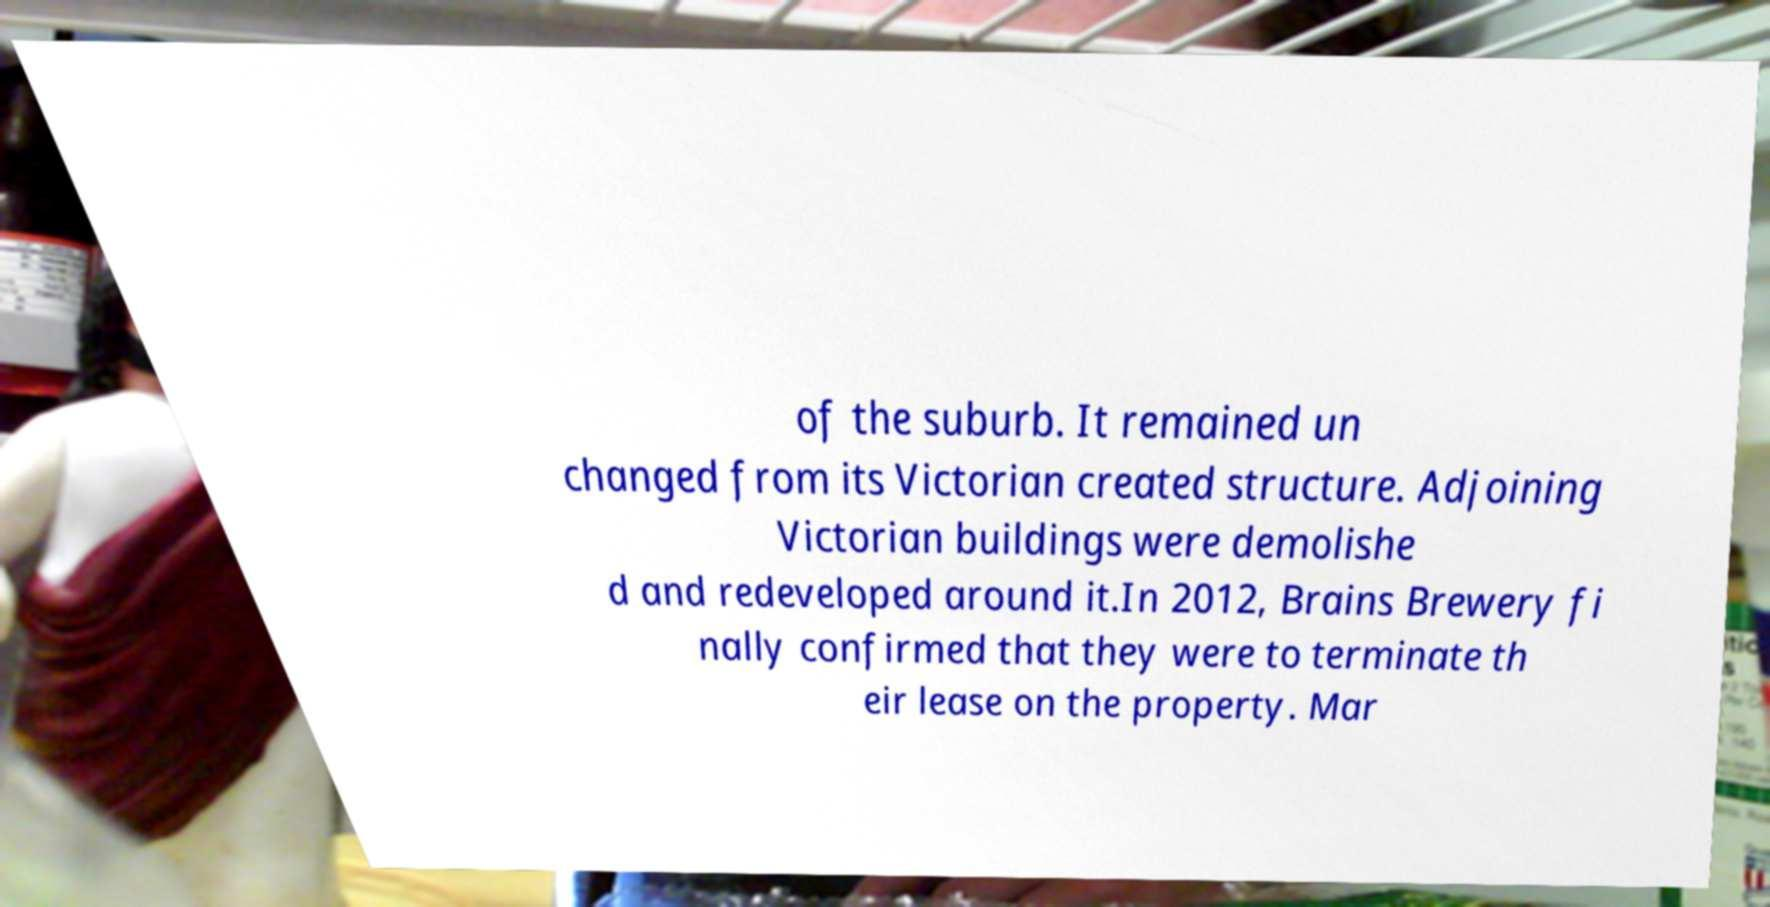Could you assist in decoding the text presented in this image and type it out clearly? of the suburb. It remained un changed from its Victorian created structure. Adjoining Victorian buildings were demolishe d and redeveloped around it.In 2012, Brains Brewery fi nally confirmed that they were to terminate th eir lease on the property. Mar 